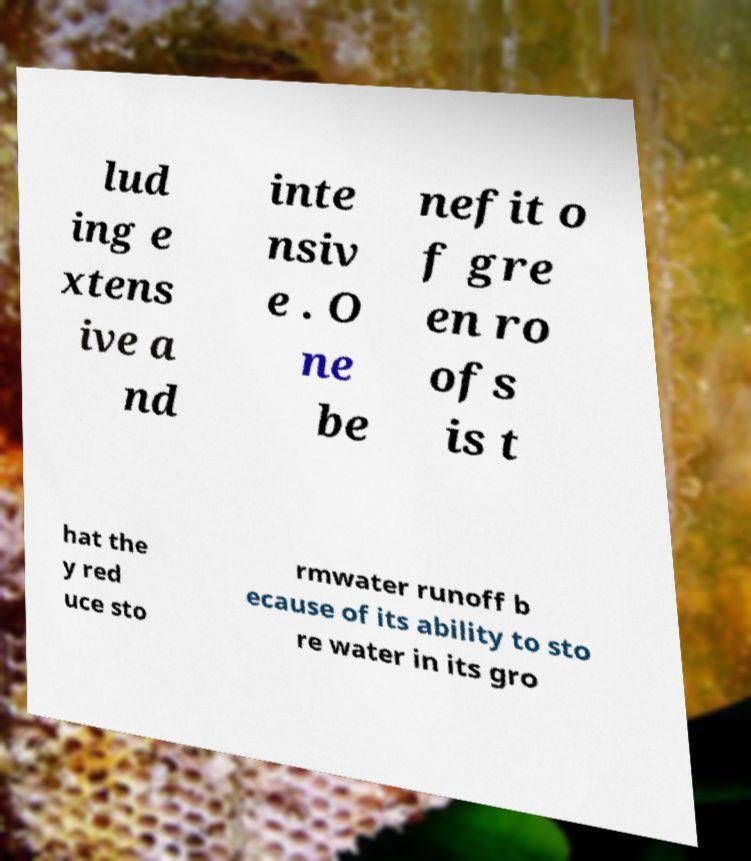For documentation purposes, I need the text within this image transcribed. Could you provide that? lud ing e xtens ive a nd inte nsiv e . O ne be nefit o f gre en ro ofs is t hat the y red uce sto rmwater runoff b ecause of its ability to sto re water in its gro 